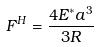<formula> <loc_0><loc_0><loc_500><loc_500>F ^ { H } = \frac { 4 E ^ { * } a ^ { 3 } } { 3 R }</formula> 